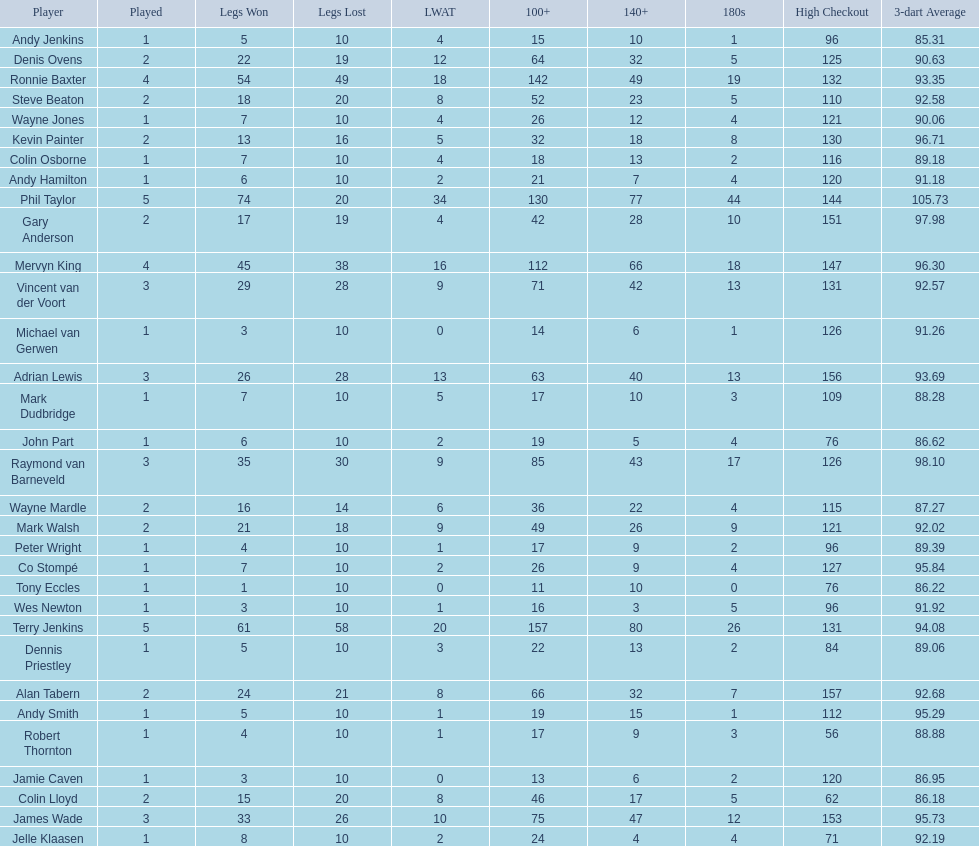Mark walsh's average is above/below 93? Below. 